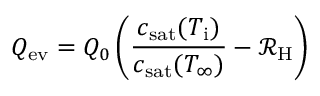Convert formula to latex. <formula><loc_0><loc_0><loc_500><loc_500>Q _ { e v } = Q _ { 0 } \left ( \frac { c _ { s a t } ( T _ { i } ) } { c _ { s a t } ( T _ { \infty } ) } - \mathcal { R } _ { H } \right )</formula> 